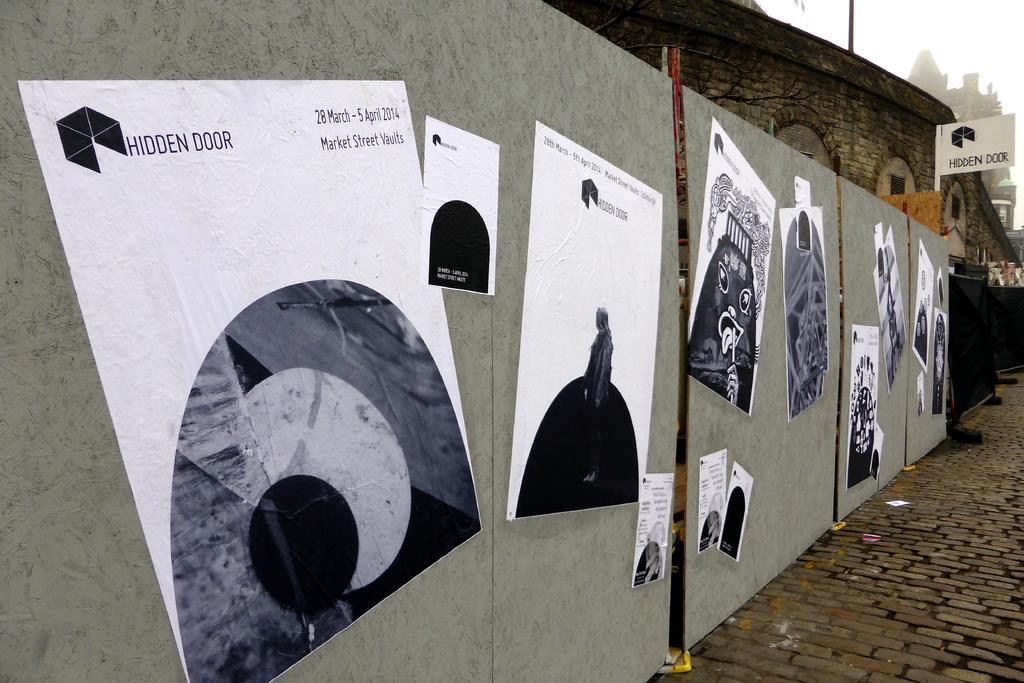Please provide a concise description of this image. In the image we can see there are many poster stick to the wooden sheet. This is a footpath, stone building, pole and a white sky. 